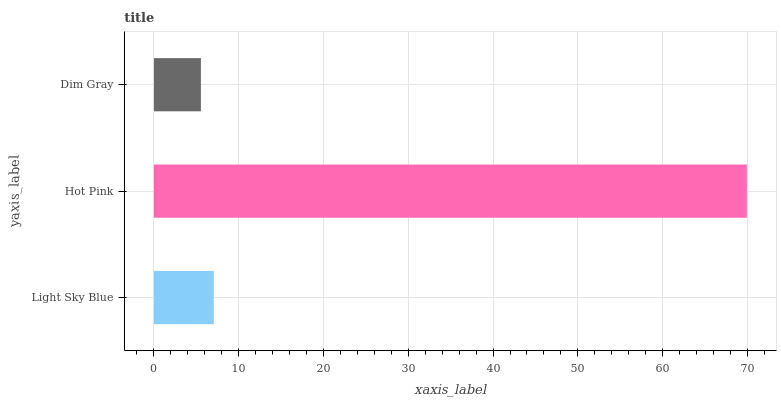Is Dim Gray the minimum?
Answer yes or no. Yes. Is Hot Pink the maximum?
Answer yes or no. Yes. Is Hot Pink the minimum?
Answer yes or no. No. Is Dim Gray the maximum?
Answer yes or no. No. Is Hot Pink greater than Dim Gray?
Answer yes or no. Yes. Is Dim Gray less than Hot Pink?
Answer yes or no. Yes. Is Dim Gray greater than Hot Pink?
Answer yes or no. No. Is Hot Pink less than Dim Gray?
Answer yes or no. No. Is Light Sky Blue the high median?
Answer yes or no. Yes. Is Light Sky Blue the low median?
Answer yes or no. Yes. Is Hot Pink the high median?
Answer yes or no. No. Is Hot Pink the low median?
Answer yes or no. No. 